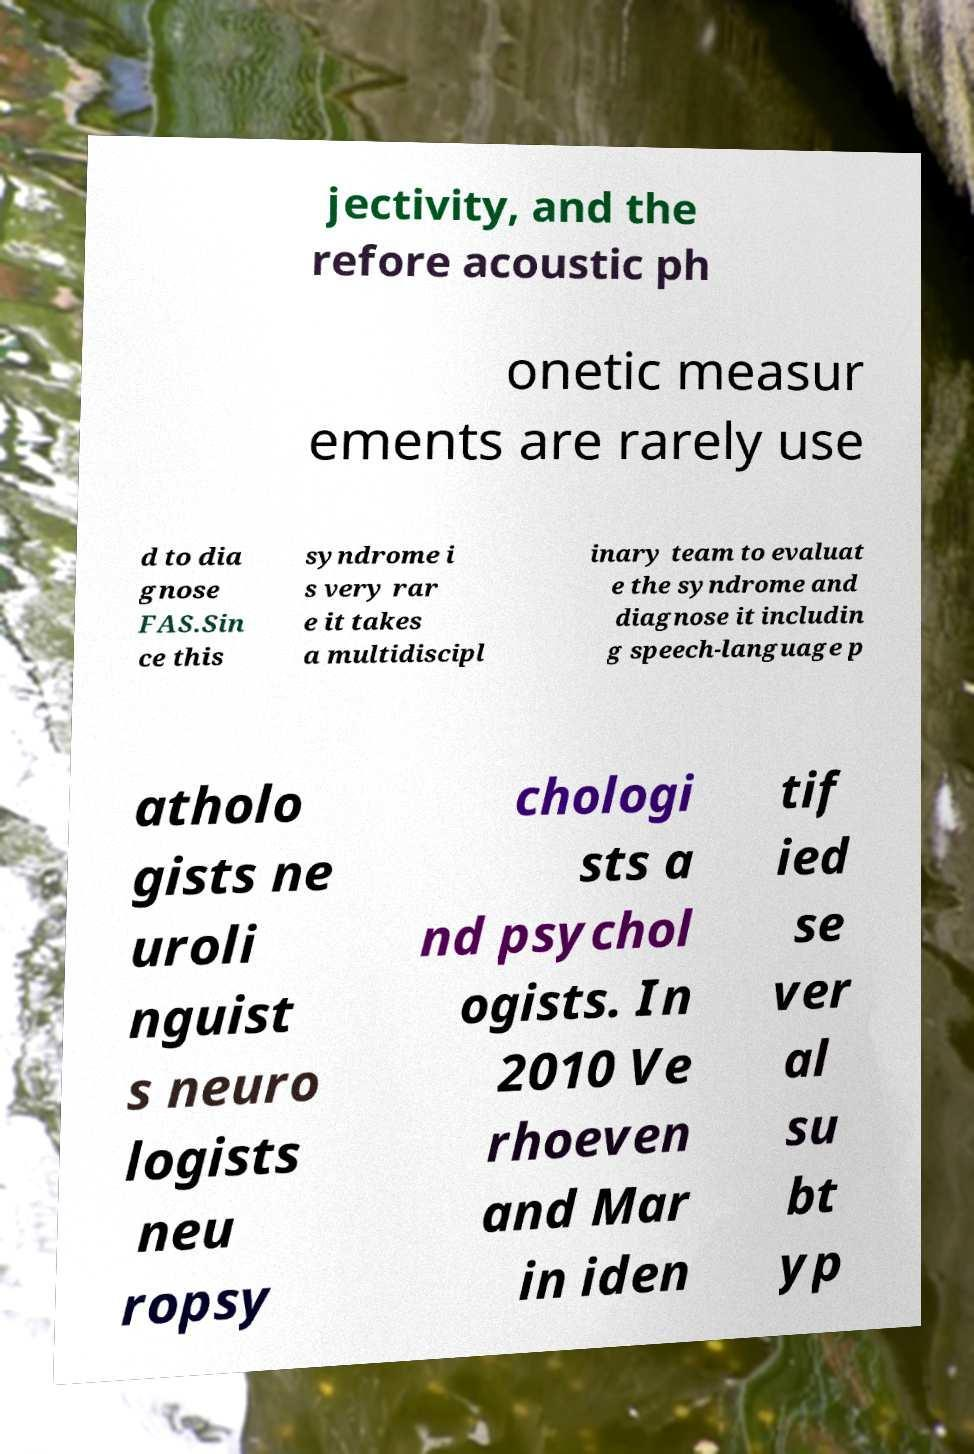Could you extract and type out the text from this image? jectivity, and the refore acoustic ph onetic measur ements are rarely use d to dia gnose FAS.Sin ce this syndrome i s very rar e it takes a multidiscipl inary team to evaluat e the syndrome and diagnose it includin g speech-language p atholo gists ne uroli nguist s neuro logists neu ropsy chologi sts a nd psychol ogists. In 2010 Ve rhoeven and Mar in iden tif ied se ver al su bt yp 